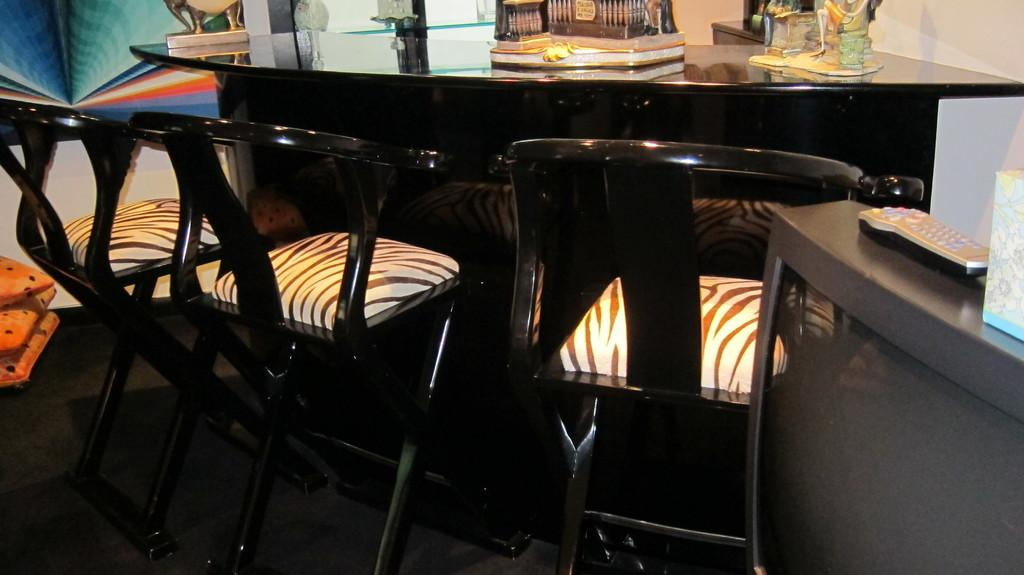What piece of furniture is present in the image? There is a table in the image. What is placed on the table? There are objects on the table. What type of seating is available near the table? There are chairs beside the table. What type of flowers can be seen growing on the chairs in the image? There are no flowers visible on the chairs in the image. 